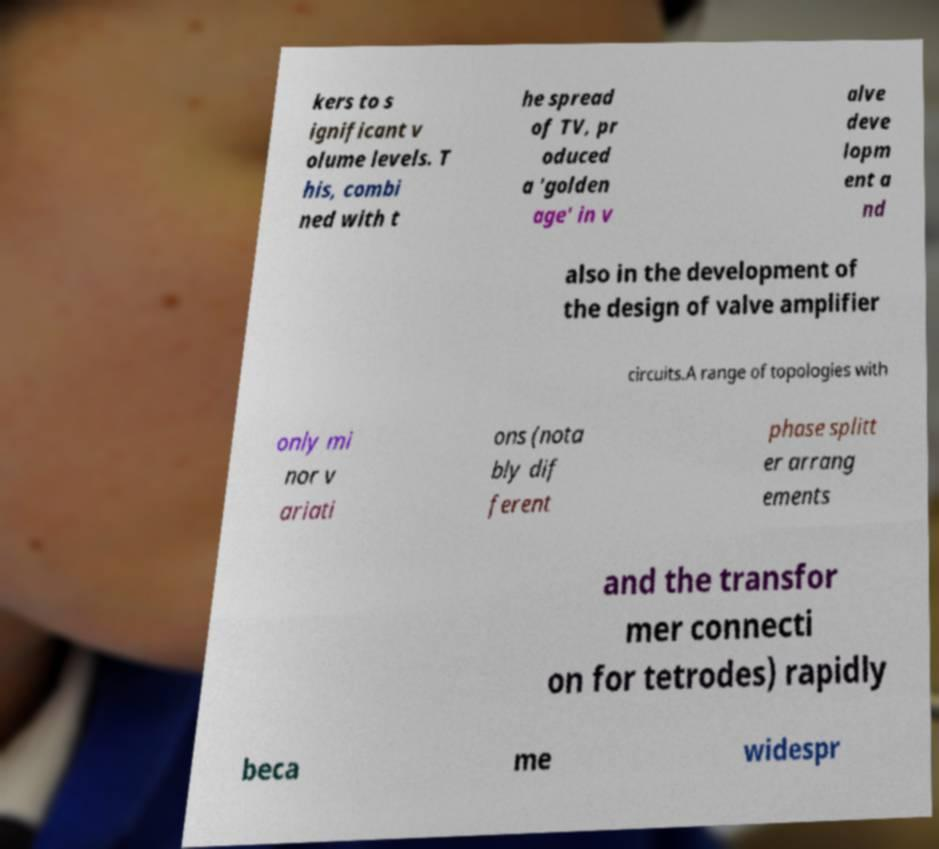Please read and relay the text visible in this image. What does it say? kers to s ignificant v olume levels. T his, combi ned with t he spread of TV, pr oduced a 'golden age' in v alve deve lopm ent a nd also in the development of the design of valve amplifier circuits.A range of topologies with only mi nor v ariati ons (nota bly dif ferent phase splitt er arrang ements and the transfor mer connecti on for tetrodes) rapidly beca me widespr 